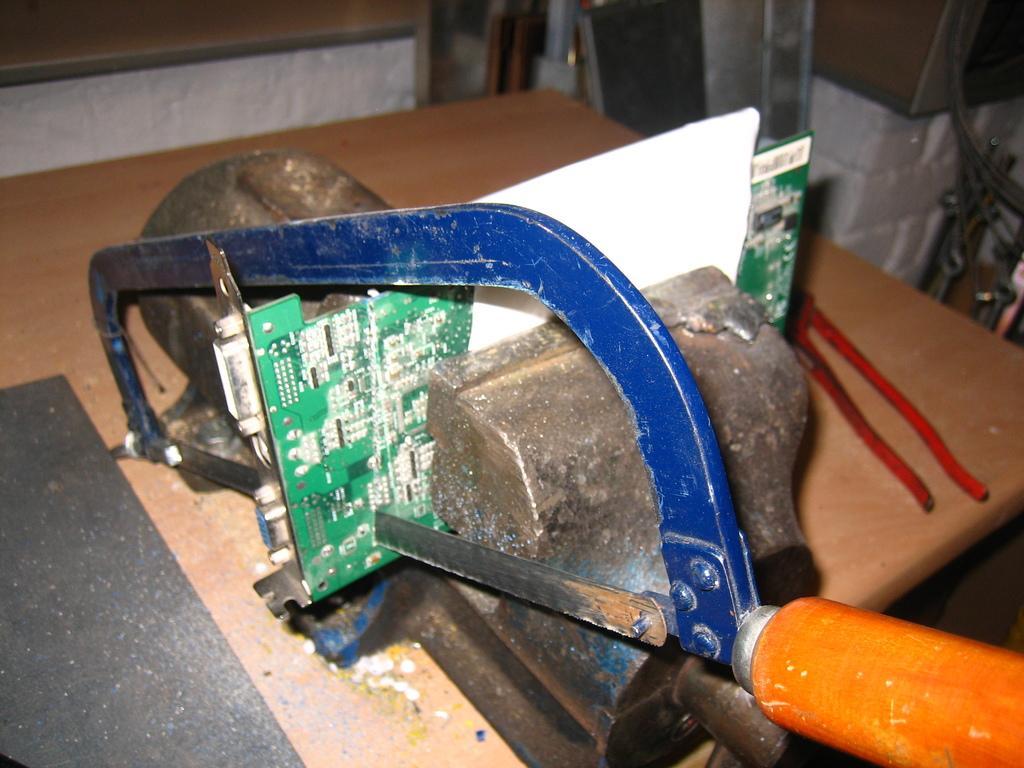Could you give a brief overview of what you see in this image? In the picture there is a mini saw, it is cutting some object and beside the saw there is a cutting player, all these things were kept on the table. 